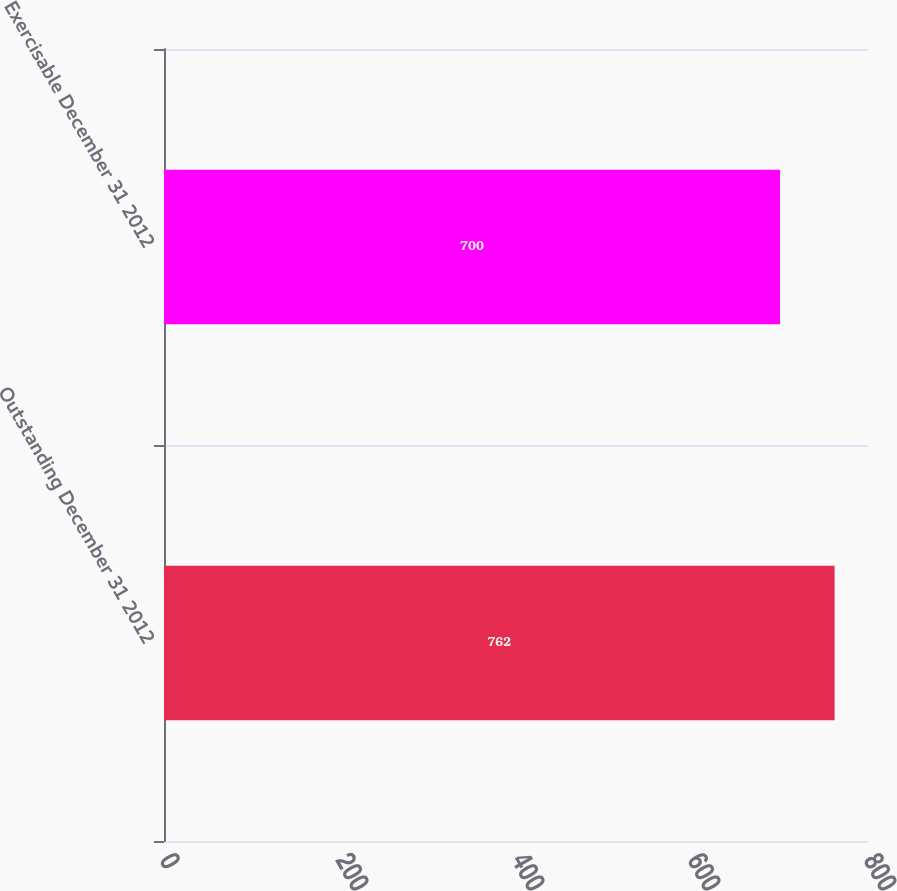Convert chart. <chart><loc_0><loc_0><loc_500><loc_500><bar_chart><fcel>Outstanding December 31 2012<fcel>Exercisable December 31 2012<nl><fcel>762<fcel>700<nl></chart> 